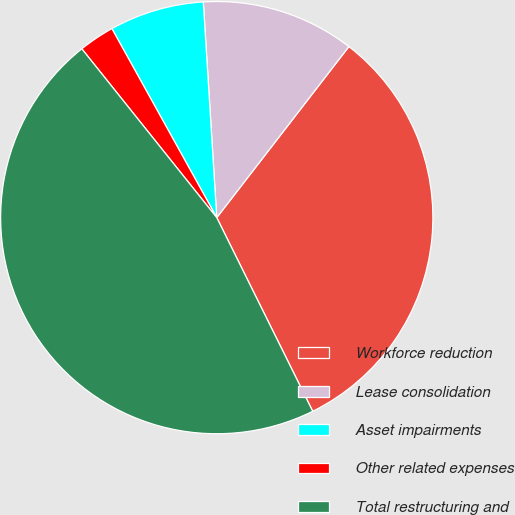<chart> <loc_0><loc_0><loc_500><loc_500><pie_chart><fcel>Workforce reduction<fcel>Lease consolidation<fcel>Asset impairments<fcel>Other related expenses<fcel>Total restructuring and<nl><fcel>32.21%<fcel>11.46%<fcel>7.07%<fcel>2.67%<fcel>46.59%<nl></chart> 